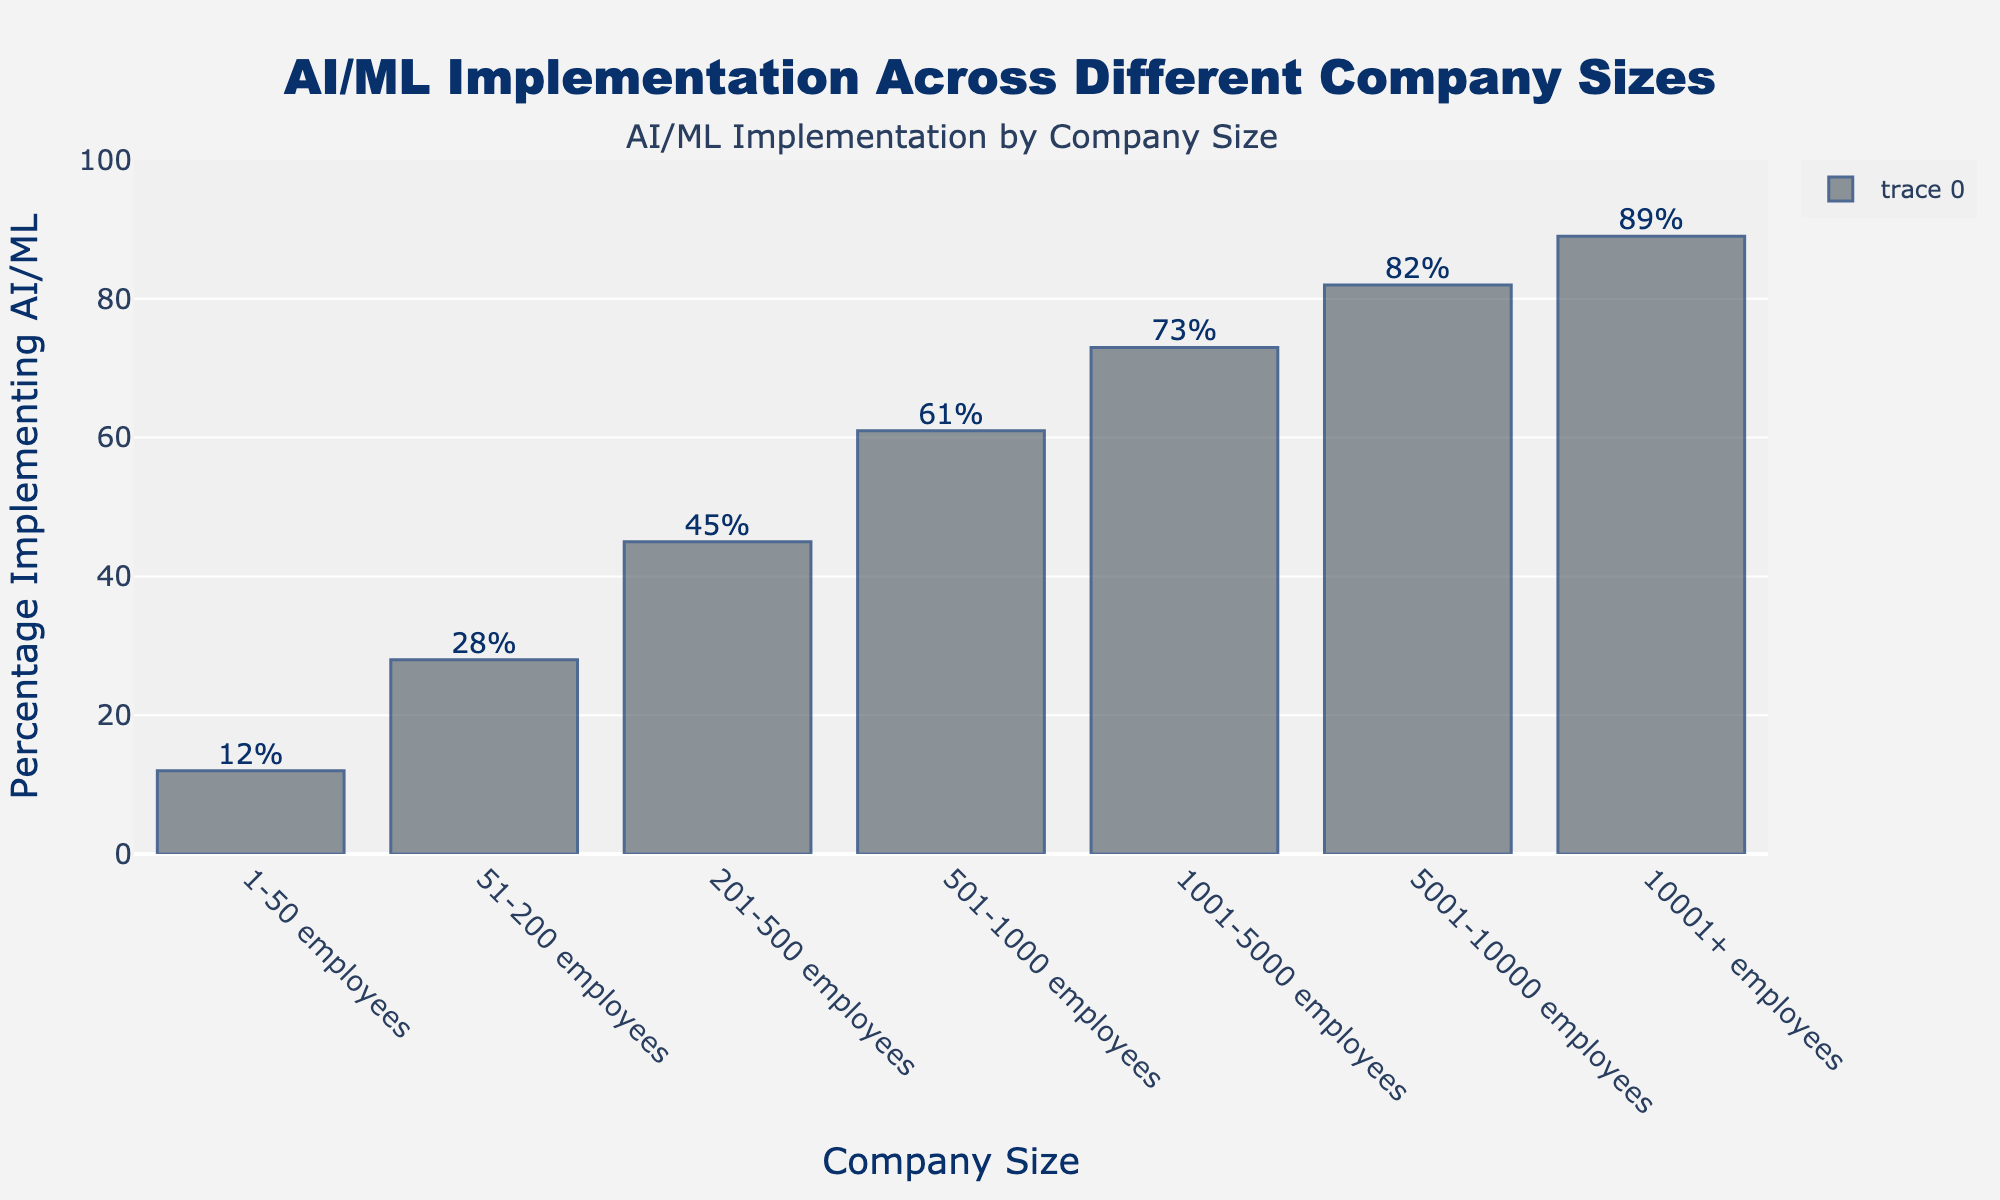What is the percentage of companies with 201-500 employees implementing AI/ML? The percentage of companies with 201-500 employees implementing AI/ML is given directly on the chart.
Answer: 45% Which company size has the highest percentage of AI/ML implementation? By looking at the bar heights, the company size with the highest percentage is "10001+ employees."
Answer: 10001+ employees How much higher is the percentage of companies with 5001-10000 employees implementing AI/ML compared to those with 1-50 employees? The percentage for 5001-10000 employees is 82% and for 1-50 employees is 12%. Subtracting these values, 82 - 12 = 70.
Answer: 70% What is the average percentage of AI/ML implementation among companies with less than 501 employees? Sum the percentages of the categories less than 501 employees (12, 28, and 45) and divide by 3. \( \frac{12 + 28 + 45}{3} = \frac{85}{3} \approx 28.3 \)
Answer: 28.3% Which company size shows the largest percentage increase in AI/ML implementation from the previous category? Calculate the percentage increase between consecutive company sizes. The largest increase is found between "201-500 employees" (45%) and "501-1000 employees" (61%), which is 61 - 45 = 16.
Answer: 501-1000 employees Is the percentage of companies with 1001-5000 employees implementing AI/ML greater than the combined percentage of companies with 1-50 and 51-200 employees? Calculate the combined percentage of 1-50 (12%) and 51-200 (28%), which is 12 + 28 = 40%. Compare this to 73% for 1001-5000 employees.
Answer: Yes How much more likely are companies with 10001+ employees to implement AI/ML compared to those with 51-200 employees? The percentage for 10001+ employees is 89%, and for 51-200 employees is 28%. Subtracting these, 89 - 28 = 61.
Answer: 61% more likely What is the range of AI/ML implementation percentages across all company sizes? The range is calculated as the difference between the highest (89% for 10001+ employees) and the lowest (12% for 1-50 employees) values. 89 - 12 = 77.
Answer: 77% Are companies with 501-1000 employees implementing AI/ML at a rate higher than the average of all companies combined? Calculate the average percentage for all companies by summing their percentages and dividing by the number of categories: \( \frac{12 + 28 + 45 + 61 + 73 + 82 + 89}{7} = 390/7 \approx 55.7 \). Compare this with 61% for 501-1000 employees.
Answer: Yes 